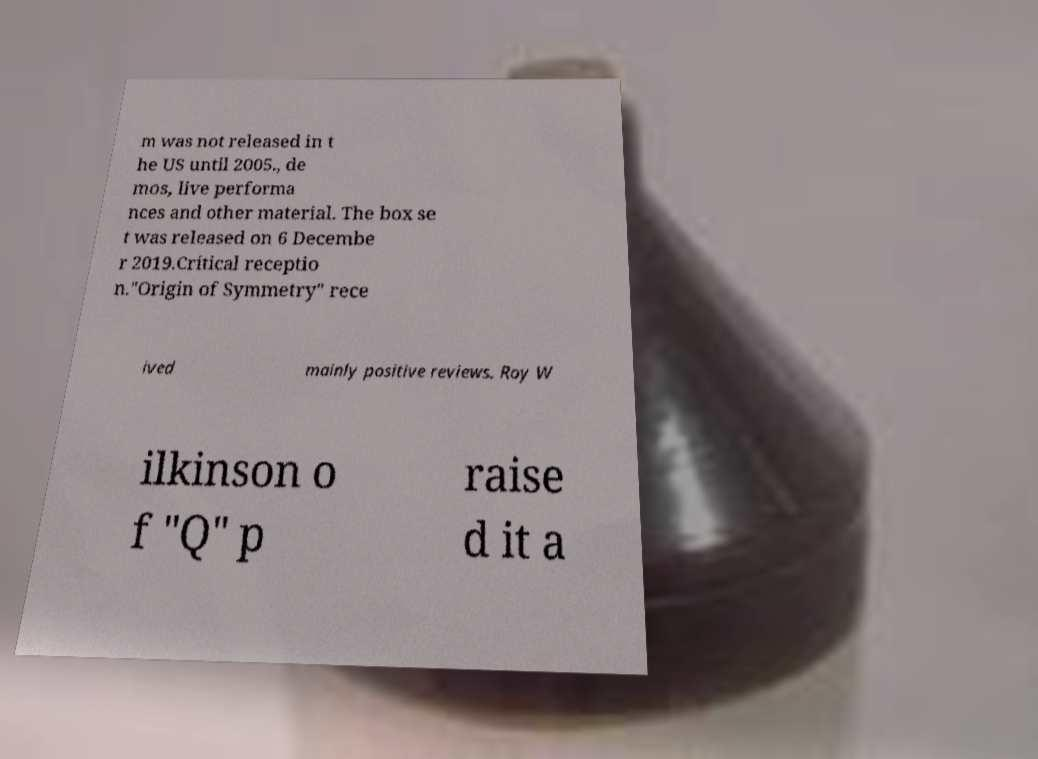Can you read and provide the text displayed in the image?This photo seems to have some interesting text. Can you extract and type it out for me? m was not released in t he US until 2005., de mos, live performa nces and other material. The box se t was released on 6 Decembe r 2019.Critical receptio n."Origin of Symmetry" rece ived mainly positive reviews. Roy W ilkinson o f "Q" p raise d it a 